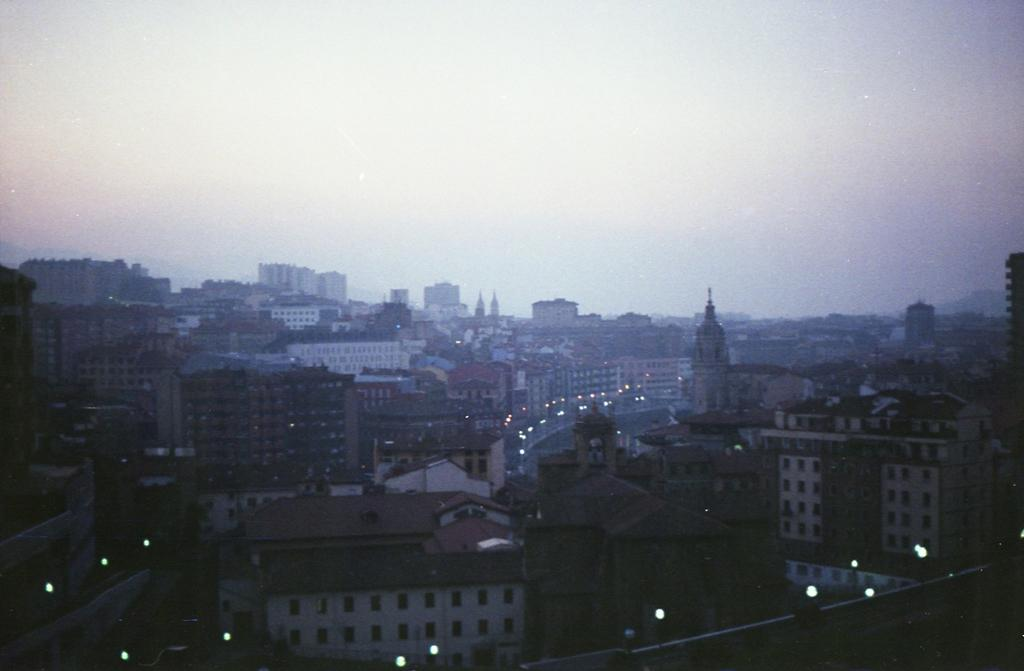What type of structures are located at the bottom of the image? There are buildings at the bottom of the image. What can be seen illuminated in the image? There are lights visible in the image. What is visible at the top of the image? The sky is visible at the top of the image. What is the tendency of the stamp in the image? There is no stamp present in the image. What type of work is being done in the image? The image does not depict any specific work being done. 